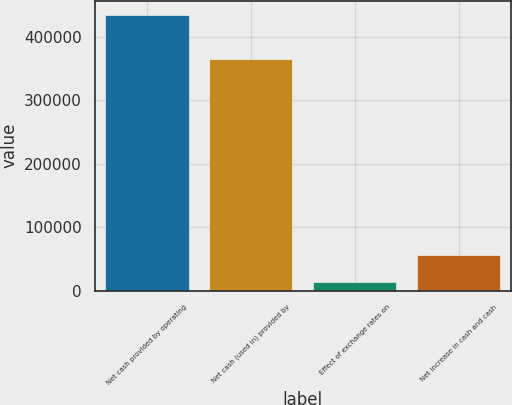Convert chart to OTSL. <chart><loc_0><loc_0><loc_500><loc_500><bar_chart><fcel>Net cash provided by operating<fcel>Net cash (used in) provided by<fcel>Effect of exchange rates on<fcel>Net increase in cash and cash<nl><fcel>434738<fcel>365274<fcel>13305<fcel>55448.3<nl></chart> 